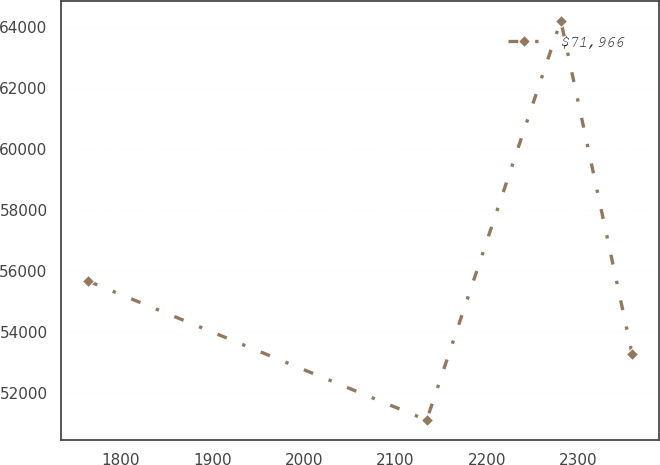Convert chart. <chart><loc_0><loc_0><loc_500><loc_500><line_chart><ecel><fcel>$71,966<nl><fcel>1764.33<fcel>55682.1<nl><fcel>2134.11<fcel>51122.4<nl><fcel>2280.54<fcel>64219.1<nl><fcel>2358.55<fcel>53278.3<nl></chart> 